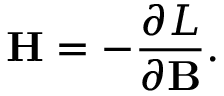Convert formula to latex. <formula><loc_0><loc_0><loc_500><loc_500>H = - \frac { \partial L } { \partial B } .</formula> 